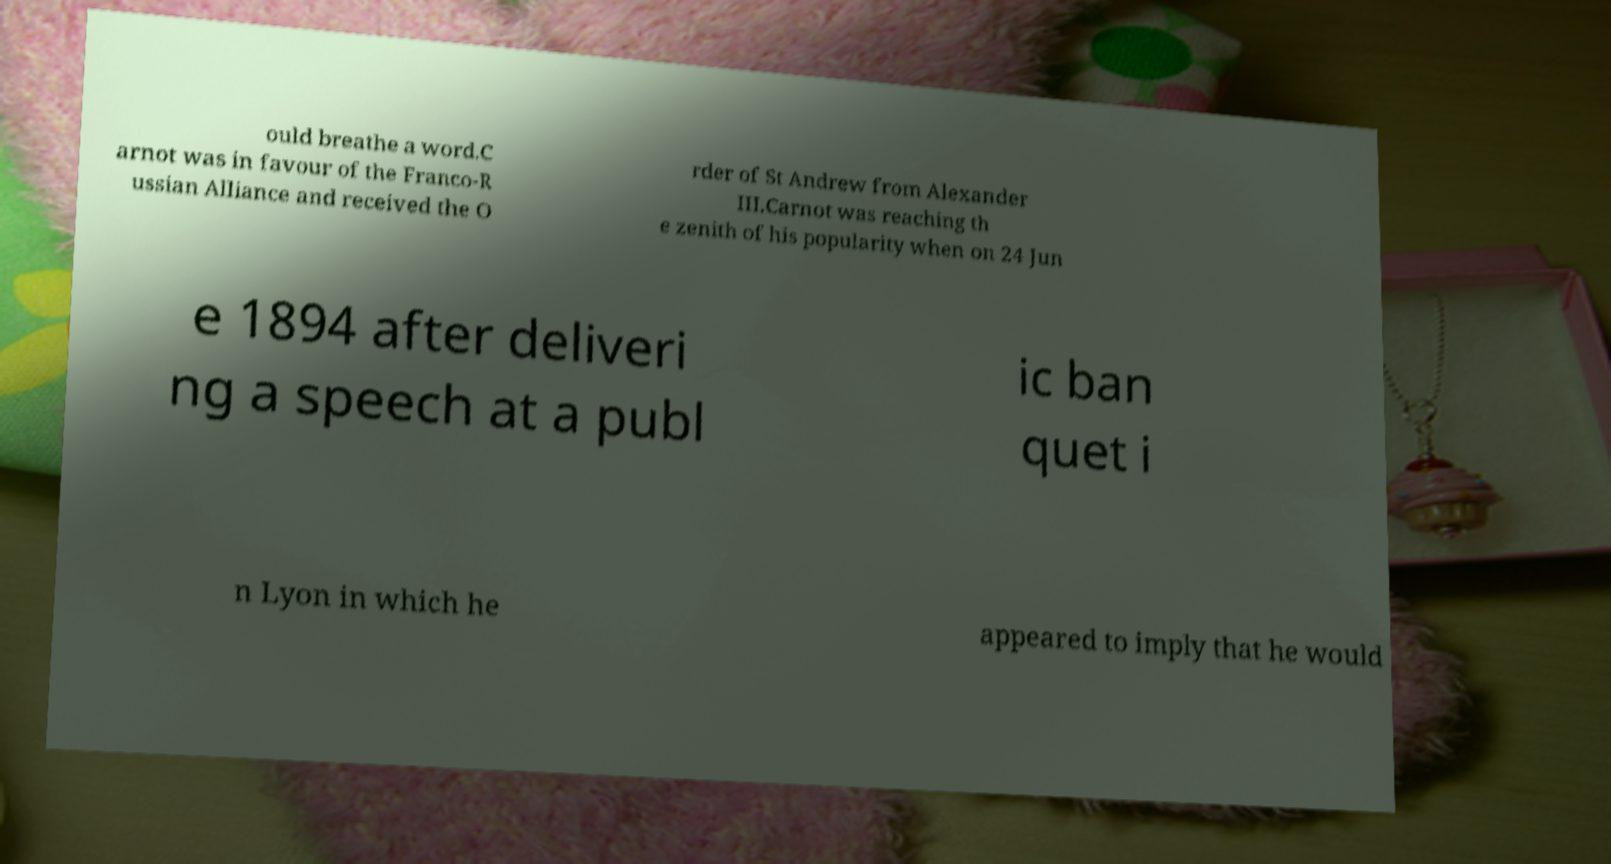Please identify and transcribe the text found in this image. ould breathe a word.C arnot was in favour of the Franco-R ussian Alliance and received the O rder of St Andrew from Alexander III.Carnot was reaching th e zenith of his popularity when on 24 Jun e 1894 after deliveri ng a speech at a publ ic ban quet i n Lyon in which he appeared to imply that he would 